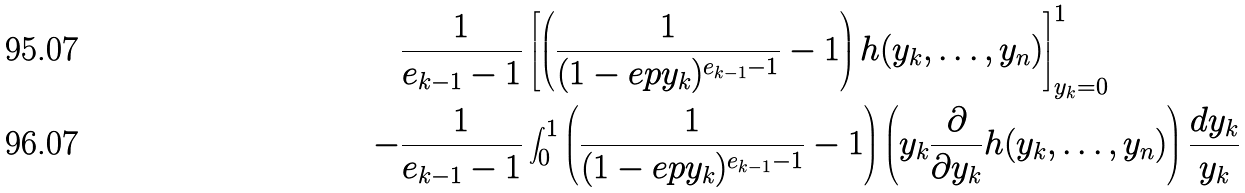Convert formula to latex. <formula><loc_0><loc_0><loc_500><loc_500>& \frac { 1 } { e _ { k - 1 } - 1 } \left [ \left ( \frac { 1 } { ( 1 - e p y _ { k } ) ^ { e _ { k - 1 } - 1 } } - 1 \right ) h ( y _ { k } , \dots , y _ { n } ) \right ] _ { y _ { k } = 0 } ^ { 1 } \\ - & \frac { 1 } { e _ { k - 1 } - 1 } \int _ { 0 } ^ { 1 } \left ( \frac { 1 } { ( 1 - e p y _ { k } ) ^ { e _ { k - 1 } - 1 } } - 1 \right ) \left ( y _ { k } \frac { \partial } { \partial y _ { k } } h ( y _ { k } , \dots , y _ { n } ) \right ) \frac { d y _ { k } } { y _ { k } }</formula> 